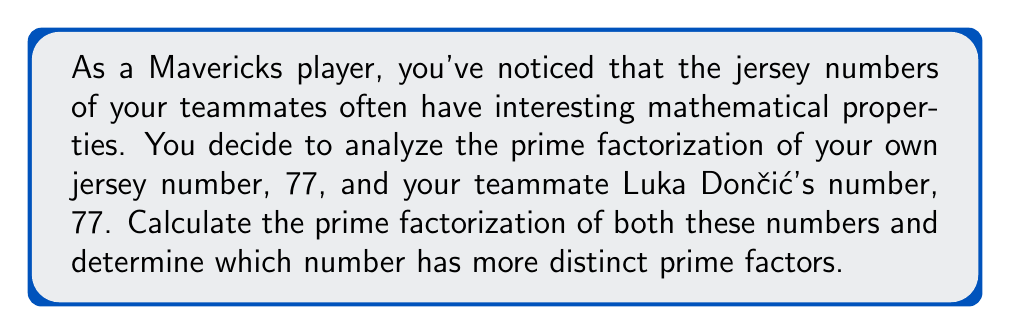Could you help me with this problem? Let's break this down step-by-step:

1. Prime factorization of 77:
   $77 = 7 \times 11$
   
   Both 7 and 11 are prime numbers, so this is the complete prime factorization.

2. Prime factorization of 77:
   $77 = 7 \times 11$
   
   This is the same as your number, as both you and Luka wear number 77.

3. Counting distinct prime factors:
   For both numbers:
   - The distinct prime factors are 7 and 11
   - The count of distinct prime factors is 2

To visualize this, we can represent the prime factorization as a product of prime powers:

$$77 = 7^1 \times 11^1$$

This representation clearly shows the two distinct prime factors (7 and 11) and their respective exponents (both 1 in this case).

Since both jersey numbers are the same, they both have the same number of distinct prime factors.
Answer: The prime factorization of both 77 and 77 is $7 \times 11$. Both numbers have 2 distinct prime factors. Therefore, neither number has more distinct prime factors than the other. 